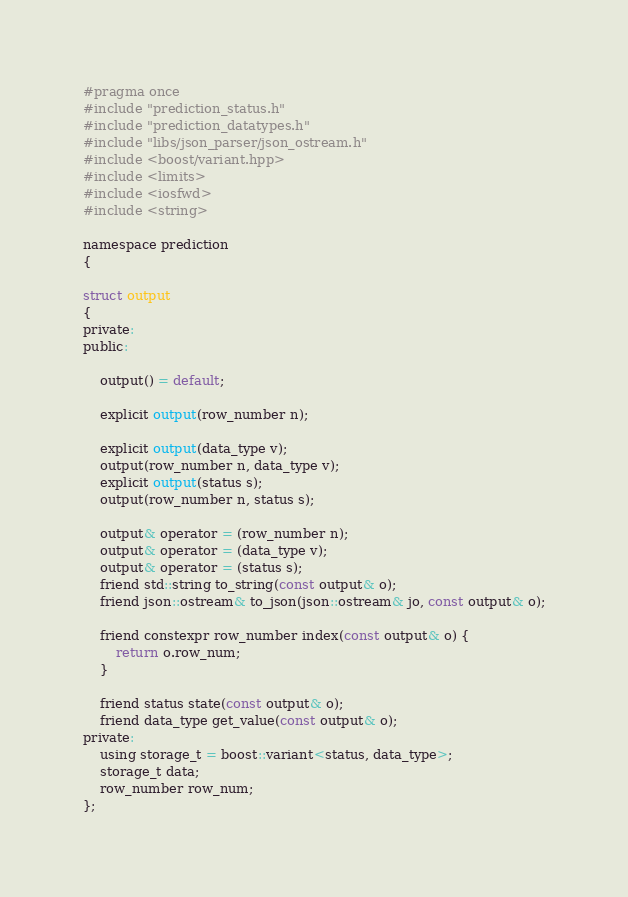<code> <loc_0><loc_0><loc_500><loc_500><_C_>#pragma once
#include "prediction_status.h"
#include "prediction_datatypes.h"
#include "libs/json_parser/json_ostream.h"
#include <boost/variant.hpp>
#include <limits>
#include <iosfwd>
#include <string>

namespace prediction
{

struct output
{
private:
public:
    
    output() = default;

    explicit output(row_number n);

    explicit output(data_type v);
    output(row_number n, data_type v);
    explicit output(status s);
    output(row_number n, status s);

    output& operator = (row_number n);
    output& operator = (data_type v);
    output& operator = (status s);
    friend std::string to_string(const output& o);
    friend json::ostream& to_json(json::ostream& jo, const output& o);

    friend constexpr row_number index(const output& o) {
        return o.row_num;
    }

    friend status state(const output& o);
    friend data_type get_value(const output& o);
private:
    using storage_t = boost::variant<status, data_type>;
    storage_t data;
    row_number row_num;
};</code> 